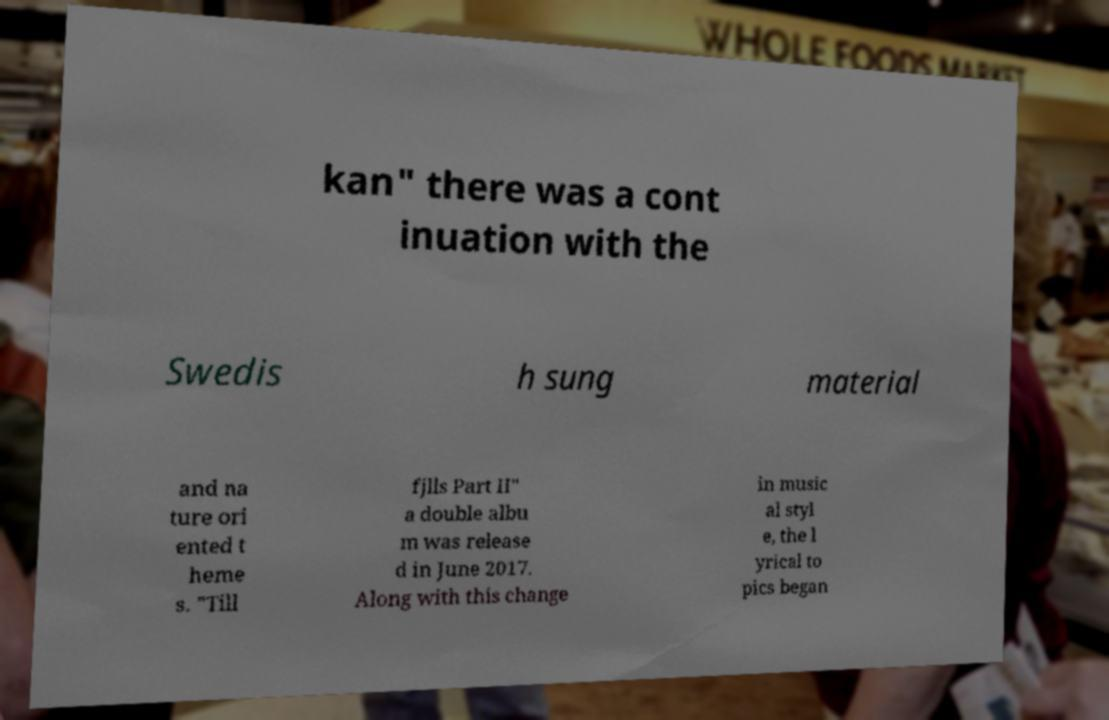Could you extract and type out the text from this image? kan" there was a cont inuation with the Swedis h sung material and na ture ori ented t heme s. "Till fjlls Part II" a double albu m was release d in June 2017. Along with this change in music al styl e, the l yrical to pics began 